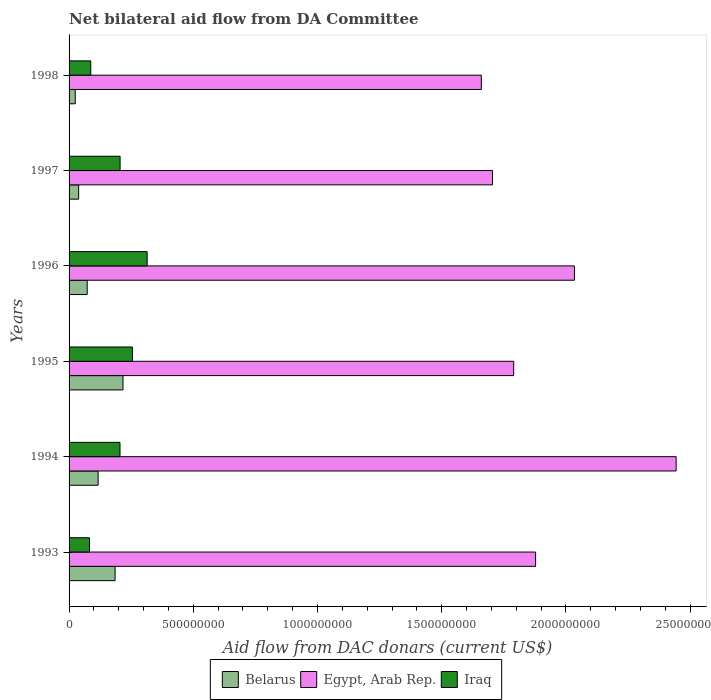How many bars are there on the 1st tick from the top?
Your answer should be compact. 3. How many bars are there on the 2nd tick from the bottom?
Your response must be concise. 3. What is the label of the 6th group of bars from the top?
Your response must be concise. 1993. In how many cases, is the number of bars for a given year not equal to the number of legend labels?
Your answer should be compact. 0. What is the aid flow in in Egypt, Arab Rep. in 1993?
Give a very brief answer. 1.88e+09. Across all years, what is the maximum aid flow in in Iraq?
Offer a very short reply. 3.14e+08. Across all years, what is the minimum aid flow in in Iraq?
Offer a very short reply. 8.23e+07. In which year was the aid flow in in Belarus maximum?
Give a very brief answer. 1995. What is the total aid flow in in Belarus in the graph?
Provide a short and direct response. 6.56e+08. What is the difference between the aid flow in in Iraq in 1995 and that in 1996?
Provide a short and direct response. -5.94e+07. What is the difference between the aid flow in in Belarus in 1998 and the aid flow in in Iraq in 1995?
Your answer should be very brief. -2.30e+08. What is the average aid flow in in Belarus per year?
Provide a succinct answer. 1.09e+08. In the year 1994, what is the difference between the aid flow in in Belarus and aid flow in in Iraq?
Give a very brief answer. -8.81e+07. In how many years, is the aid flow in in Iraq greater than 200000000 US$?
Your answer should be very brief. 4. What is the ratio of the aid flow in in Iraq in 1993 to that in 1997?
Keep it short and to the point. 0.4. Is the aid flow in in Egypt, Arab Rep. in 1996 less than that in 1998?
Make the answer very short. No. Is the difference between the aid flow in in Belarus in 1994 and 1998 greater than the difference between the aid flow in in Iraq in 1994 and 1998?
Your answer should be very brief. No. What is the difference between the highest and the second highest aid flow in in Egypt, Arab Rep.?
Provide a short and direct response. 4.09e+08. What is the difference between the highest and the lowest aid flow in in Iraq?
Your answer should be very brief. 2.32e+08. In how many years, is the aid flow in in Belarus greater than the average aid flow in in Belarus taken over all years?
Give a very brief answer. 3. Is the sum of the aid flow in in Belarus in 1995 and 1996 greater than the maximum aid flow in in Iraq across all years?
Give a very brief answer. No. What does the 2nd bar from the top in 1997 represents?
Provide a short and direct response. Egypt, Arab Rep. What does the 2nd bar from the bottom in 1998 represents?
Give a very brief answer. Egypt, Arab Rep. How many bars are there?
Make the answer very short. 18. Are all the bars in the graph horizontal?
Your answer should be compact. Yes. How many years are there in the graph?
Your response must be concise. 6. What is the difference between two consecutive major ticks on the X-axis?
Your answer should be compact. 5.00e+08. Are the values on the major ticks of X-axis written in scientific E-notation?
Your answer should be very brief. No. Does the graph contain any zero values?
Ensure brevity in your answer.  No. Does the graph contain grids?
Provide a short and direct response. No. How many legend labels are there?
Your answer should be very brief. 3. How are the legend labels stacked?
Make the answer very short. Horizontal. What is the title of the graph?
Make the answer very short. Net bilateral aid flow from DA Committee. What is the label or title of the X-axis?
Your response must be concise. Aid flow from DAC donars (current US$). What is the Aid flow from DAC donars (current US$) in Belarus in 1993?
Your answer should be compact. 1.85e+08. What is the Aid flow from DAC donars (current US$) of Egypt, Arab Rep. in 1993?
Your response must be concise. 1.88e+09. What is the Aid flow from DAC donars (current US$) of Iraq in 1993?
Offer a very short reply. 8.23e+07. What is the Aid flow from DAC donars (current US$) in Belarus in 1994?
Your response must be concise. 1.17e+08. What is the Aid flow from DAC donars (current US$) of Egypt, Arab Rep. in 1994?
Make the answer very short. 2.44e+09. What is the Aid flow from DAC donars (current US$) of Iraq in 1994?
Give a very brief answer. 2.05e+08. What is the Aid flow from DAC donars (current US$) of Belarus in 1995?
Ensure brevity in your answer.  2.17e+08. What is the Aid flow from DAC donars (current US$) in Egypt, Arab Rep. in 1995?
Provide a short and direct response. 1.79e+09. What is the Aid flow from DAC donars (current US$) of Iraq in 1995?
Your response must be concise. 2.55e+08. What is the Aid flow from DAC donars (current US$) of Belarus in 1996?
Provide a short and direct response. 7.30e+07. What is the Aid flow from DAC donars (current US$) in Egypt, Arab Rep. in 1996?
Provide a short and direct response. 2.03e+09. What is the Aid flow from DAC donars (current US$) of Iraq in 1996?
Offer a terse response. 3.14e+08. What is the Aid flow from DAC donars (current US$) in Belarus in 1997?
Keep it short and to the point. 3.86e+07. What is the Aid flow from DAC donars (current US$) of Egypt, Arab Rep. in 1997?
Make the answer very short. 1.70e+09. What is the Aid flow from DAC donars (current US$) of Iraq in 1997?
Provide a short and direct response. 2.05e+08. What is the Aid flow from DAC donars (current US$) in Belarus in 1998?
Ensure brevity in your answer.  2.49e+07. What is the Aid flow from DAC donars (current US$) of Egypt, Arab Rep. in 1998?
Your response must be concise. 1.66e+09. What is the Aid flow from DAC donars (current US$) of Iraq in 1998?
Your response must be concise. 8.74e+07. Across all years, what is the maximum Aid flow from DAC donars (current US$) in Belarus?
Offer a terse response. 2.17e+08. Across all years, what is the maximum Aid flow from DAC donars (current US$) in Egypt, Arab Rep.?
Provide a succinct answer. 2.44e+09. Across all years, what is the maximum Aid flow from DAC donars (current US$) of Iraq?
Offer a terse response. 3.14e+08. Across all years, what is the minimum Aid flow from DAC donars (current US$) in Belarus?
Make the answer very short. 2.49e+07. Across all years, what is the minimum Aid flow from DAC donars (current US$) of Egypt, Arab Rep.?
Keep it short and to the point. 1.66e+09. Across all years, what is the minimum Aid flow from DAC donars (current US$) of Iraq?
Your response must be concise. 8.23e+07. What is the total Aid flow from DAC donars (current US$) in Belarus in the graph?
Make the answer very short. 6.56e+08. What is the total Aid flow from DAC donars (current US$) in Egypt, Arab Rep. in the graph?
Provide a succinct answer. 1.15e+1. What is the total Aid flow from DAC donars (current US$) of Iraq in the graph?
Your answer should be compact. 1.15e+09. What is the difference between the Aid flow from DAC donars (current US$) of Belarus in 1993 and that in 1994?
Your answer should be compact. 6.83e+07. What is the difference between the Aid flow from DAC donars (current US$) of Egypt, Arab Rep. in 1993 and that in 1994?
Provide a succinct answer. -5.66e+08. What is the difference between the Aid flow from DAC donars (current US$) of Iraq in 1993 and that in 1994?
Your response must be concise. -1.23e+08. What is the difference between the Aid flow from DAC donars (current US$) in Belarus in 1993 and that in 1995?
Ensure brevity in your answer.  -3.19e+07. What is the difference between the Aid flow from DAC donars (current US$) of Egypt, Arab Rep. in 1993 and that in 1995?
Keep it short and to the point. 8.82e+07. What is the difference between the Aid flow from DAC donars (current US$) of Iraq in 1993 and that in 1995?
Make the answer very short. -1.73e+08. What is the difference between the Aid flow from DAC donars (current US$) of Belarus in 1993 and that in 1996?
Offer a very short reply. 1.12e+08. What is the difference between the Aid flow from DAC donars (current US$) of Egypt, Arab Rep. in 1993 and that in 1996?
Provide a short and direct response. -1.56e+08. What is the difference between the Aid flow from DAC donars (current US$) of Iraq in 1993 and that in 1996?
Provide a succinct answer. -2.32e+08. What is the difference between the Aid flow from DAC donars (current US$) of Belarus in 1993 and that in 1997?
Give a very brief answer. 1.47e+08. What is the difference between the Aid flow from DAC donars (current US$) in Egypt, Arab Rep. in 1993 and that in 1997?
Your response must be concise. 1.73e+08. What is the difference between the Aid flow from DAC donars (current US$) of Iraq in 1993 and that in 1997?
Your response must be concise. -1.23e+08. What is the difference between the Aid flow from DAC donars (current US$) of Belarus in 1993 and that in 1998?
Your answer should be very brief. 1.60e+08. What is the difference between the Aid flow from DAC donars (current US$) of Egypt, Arab Rep. in 1993 and that in 1998?
Provide a short and direct response. 2.18e+08. What is the difference between the Aid flow from DAC donars (current US$) of Iraq in 1993 and that in 1998?
Offer a very short reply. -5.08e+06. What is the difference between the Aid flow from DAC donars (current US$) of Belarus in 1994 and that in 1995?
Give a very brief answer. -1.00e+08. What is the difference between the Aid flow from DAC donars (current US$) in Egypt, Arab Rep. in 1994 and that in 1995?
Provide a short and direct response. 6.54e+08. What is the difference between the Aid flow from DAC donars (current US$) in Iraq in 1994 and that in 1995?
Offer a terse response. -4.99e+07. What is the difference between the Aid flow from DAC donars (current US$) in Belarus in 1994 and that in 1996?
Keep it short and to the point. 4.39e+07. What is the difference between the Aid flow from DAC donars (current US$) of Egypt, Arab Rep. in 1994 and that in 1996?
Make the answer very short. 4.09e+08. What is the difference between the Aid flow from DAC donars (current US$) of Iraq in 1994 and that in 1996?
Your answer should be compact. -1.09e+08. What is the difference between the Aid flow from DAC donars (current US$) in Belarus in 1994 and that in 1997?
Offer a terse response. 7.83e+07. What is the difference between the Aid flow from DAC donars (current US$) in Egypt, Arab Rep. in 1994 and that in 1997?
Your response must be concise. 7.39e+08. What is the difference between the Aid flow from DAC donars (current US$) of Iraq in 1994 and that in 1997?
Provide a succinct answer. -3.50e+05. What is the difference between the Aid flow from DAC donars (current US$) in Belarus in 1994 and that in 1998?
Your response must be concise. 9.20e+07. What is the difference between the Aid flow from DAC donars (current US$) of Egypt, Arab Rep. in 1994 and that in 1998?
Give a very brief answer. 7.84e+08. What is the difference between the Aid flow from DAC donars (current US$) in Iraq in 1994 and that in 1998?
Your answer should be very brief. 1.18e+08. What is the difference between the Aid flow from DAC donars (current US$) in Belarus in 1995 and that in 1996?
Provide a succinct answer. 1.44e+08. What is the difference between the Aid flow from DAC donars (current US$) of Egypt, Arab Rep. in 1995 and that in 1996?
Your response must be concise. -2.45e+08. What is the difference between the Aid flow from DAC donars (current US$) of Iraq in 1995 and that in 1996?
Make the answer very short. -5.94e+07. What is the difference between the Aid flow from DAC donars (current US$) in Belarus in 1995 and that in 1997?
Your answer should be compact. 1.78e+08. What is the difference between the Aid flow from DAC donars (current US$) of Egypt, Arab Rep. in 1995 and that in 1997?
Ensure brevity in your answer.  8.53e+07. What is the difference between the Aid flow from DAC donars (current US$) of Iraq in 1995 and that in 1997?
Your answer should be compact. 4.95e+07. What is the difference between the Aid flow from DAC donars (current US$) in Belarus in 1995 and that in 1998?
Ensure brevity in your answer.  1.92e+08. What is the difference between the Aid flow from DAC donars (current US$) in Egypt, Arab Rep. in 1995 and that in 1998?
Offer a terse response. 1.30e+08. What is the difference between the Aid flow from DAC donars (current US$) in Iraq in 1995 and that in 1998?
Your answer should be compact. 1.67e+08. What is the difference between the Aid flow from DAC donars (current US$) in Belarus in 1996 and that in 1997?
Offer a very short reply. 3.43e+07. What is the difference between the Aid flow from DAC donars (current US$) in Egypt, Arab Rep. in 1996 and that in 1997?
Make the answer very short. 3.30e+08. What is the difference between the Aid flow from DAC donars (current US$) of Iraq in 1996 and that in 1997?
Offer a very short reply. 1.09e+08. What is the difference between the Aid flow from DAC donars (current US$) in Belarus in 1996 and that in 1998?
Give a very brief answer. 4.81e+07. What is the difference between the Aid flow from DAC donars (current US$) of Egypt, Arab Rep. in 1996 and that in 1998?
Your answer should be compact. 3.75e+08. What is the difference between the Aid flow from DAC donars (current US$) of Iraq in 1996 and that in 1998?
Your response must be concise. 2.27e+08. What is the difference between the Aid flow from DAC donars (current US$) of Belarus in 1997 and that in 1998?
Provide a succinct answer. 1.38e+07. What is the difference between the Aid flow from DAC donars (current US$) of Egypt, Arab Rep. in 1997 and that in 1998?
Your response must be concise. 4.49e+07. What is the difference between the Aid flow from DAC donars (current US$) of Iraq in 1997 and that in 1998?
Give a very brief answer. 1.18e+08. What is the difference between the Aid flow from DAC donars (current US$) in Belarus in 1993 and the Aid flow from DAC donars (current US$) in Egypt, Arab Rep. in 1994?
Offer a very short reply. -2.26e+09. What is the difference between the Aid flow from DAC donars (current US$) of Belarus in 1993 and the Aid flow from DAC donars (current US$) of Iraq in 1994?
Offer a terse response. -1.98e+07. What is the difference between the Aid flow from DAC donars (current US$) of Egypt, Arab Rep. in 1993 and the Aid flow from DAC donars (current US$) of Iraq in 1994?
Offer a terse response. 1.67e+09. What is the difference between the Aid flow from DAC donars (current US$) in Belarus in 1993 and the Aid flow from DAC donars (current US$) in Egypt, Arab Rep. in 1995?
Your answer should be compact. -1.60e+09. What is the difference between the Aid flow from DAC donars (current US$) of Belarus in 1993 and the Aid flow from DAC donars (current US$) of Iraq in 1995?
Ensure brevity in your answer.  -6.97e+07. What is the difference between the Aid flow from DAC donars (current US$) of Egypt, Arab Rep. in 1993 and the Aid flow from DAC donars (current US$) of Iraq in 1995?
Offer a very short reply. 1.62e+09. What is the difference between the Aid flow from DAC donars (current US$) in Belarus in 1993 and the Aid flow from DAC donars (current US$) in Egypt, Arab Rep. in 1996?
Give a very brief answer. -1.85e+09. What is the difference between the Aid flow from DAC donars (current US$) of Belarus in 1993 and the Aid flow from DAC donars (current US$) of Iraq in 1996?
Ensure brevity in your answer.  -1.29e+08. What is the difference between the Aid flow from DAC donars (current US$) in Egypt, Arab Rep. in 1993 and the Aid flow from DAC donars (current US$) in Iraq in 1996?
Your answer should be compact. 1.56e+09. What is the difference between the Aid flow from DAC donars (current US$) of Belarus in 1993 and the Aid flow from DAC donars (current US$) of Egypt, Arab Rep. in 1997?
Provide a succinct answer. -1.52e+09. What is the difference between the Aid flow from DAC donars (current US$) of Belarus in 1993 and the Aid flow from DAC donars (current US$) of Iraq in 1997?
Keep it short and to the point. -2.02e+07. What is the difference between the Aid flow from DAC donars (current US$) in Egypt, Arab Rep. in 1993 and the Aid flow from DAC donars (current US$) in Iraq in 1997?
Provide a succinct answer. 1.67e+09. What is the difference between the Aid flow from DAC donars (current US$) of Belarus in 1993 and the Aid flow from DAC donars (current US$) of Egypt, Arab Rep. in 1998?
Your response must be concise. -1.47e+09. What is the difference between the Aid flow from DAC donars (current US$) of Belarus in 1993 and the Aid flow from DAC donars (current US$) of Iraq in 1998?
Give a very brief answer. 9.78e+07. What is the difference between the Aid flow from DAC donars (current US$) of Egypt, Arab Rep. in 1993 and the Aid flow from DAC donars (current US$) of Iraq in 1998?
Provide a short and direct response. 1.79e+09. What is the difference between the Aid flow from DAC donars (current US$) of Belarus in 1994 and the Aid flow from DAC donars (current US$) of Egypt, Arab Rep. in 1995?
Keep it short and to the point. -1.67e+09. What is the difference between the Aid flow from DAC donars (current US$) of Belarus in 1994 and the Aid flow from DAC donars (current US$) of Iraq in 1995?
Give a very brief answer. -1.38e+08. What is the difference between the Aid flow from DAC donars (current US$) of Egypt, Arab Rep. in 1994 and the Aid flow from DAC donars (current US$) of Iraq in 1995?
Offer a very short reply. 2.19e+09. What is the difference between the Aid flow from DAC donars (current US$) in Belarus in 1994 and the Aid flow from DAC donars (current US$) in Egypt, Arab Rep. in 1996?
Make the answer very short. -1.92e+09. What is the difference between the Aid flow from DAC donars (current US$) of Belarus in 1994 and the Aid flow from DAC donars (current US$) of Iraq in 1996?
Offer a very short reply. -1.97e+08. What is the difference between the Aid flow from DAC donars (current US$) of Egypt, Arab Rep. in 1994 and the Aid flow from DAC donars (current US$) of Iraq in 1996?
Keep it short and to the point. 2.13e+09. What is the difference between the Aid flow from DAC donars (current US$) of Belarus in 1994 and the Aid flow from DAC donars (current US$) of Egypt, Arab Rep. in 1997?
Your answer should be very brief. -1.59e+09. What is the difference between the Aid flow from DAC donars (current US$) in Belarus in 1994 and the Aid flow from DAC donars (current US$) in Iraq in 1997?
Offer a very short reply. -8.85e+07. What is the difference between the Aid flow from DAC donars (current US$) in Egypt, Arab Rep. in 1994 and the Aid flow from DAC donars (current US$) in Iraq in 1997?
Offer a terse response. 2.24e+09. What is the difference between the Aid flow from DAC donars (current US$) in Belarus in 1994 and the Aid flow from DAC donars (current US$) in Egypt, Arab Rep. in 1998?
Ensure brevity in your answer.  -1.54e+09. What is the difference between the Aid flow from DAC donars (current US$) in Belarus in 1994 and the Aid flow from DAC donars (current US$) in Iraq in 1998?
Your response must be concise. 2.95e+07. What is the difference between the Aid flow from DAC donars (current US$) in Egypt, Arab Rep. in 1994 and the Aid flow from DAC donars (current US$) in Iraq in 1998?
Make the answer very short. 2.36e+09. What is the difference between the Aid flow from DAC donars (current US$) in Belarus in 1995 and the Aid flow from DAC donars (current US$) in Egypt, Arab Rep. in 1996?
Offer a very short reply. -1.82e+09. What is the difference between the Aid flow from DAC donars (current US$) in Belarus in 1995 and the Aid flow from DAC donars (current US$) in Iraq in 1996?
Keep it short and to the point. -9.72e+07. What is the difference between the Aid flow from DAC donars (current US$) of Egypt, Arab Rep. in 1995 and the Aid flow from DAC donars (current US$) of Iraq in 1996?
Provide a short and direct response. 1.48e+09. What is the difference between the Aid flow from DAC donars (current US$) of Belarus in 1995 and the Aid flow from DAC donars (current US$) of Egypt, Arab Rep. in 1997?
Your response must be concise. -1.49e+09. What is the difference between the Aid flow from DAC donars (current US$) of Belarus in 1995 and the Aid flow from DAC donars (current US$) of Iraq in 1997?
Ensure brevity in your answer.  1.17e+07. What is the difference between the Aid flow from DAC donars (current US$) in Egypt, Arab Rep. in 1995 and the Aid flow from DAC donars (current US$) in Iraq in 1997?
Make the answer very short. 1.58e+09. What is the difference between the Aid flow from DAC donars (current US$) of Belarus in 1995 and the Aid flow from DAC donars (current US$) of Egypt, Arab Rep. in 1998?
Your answer should be compact. -1.44e+09. What is the difference between the Aid flow from DAC donars (current US$) in Belarus in 1995 and the Aid flow from DAC donars (current US$) in Iraq in 1998?
Your response must be concise. 1.30e+08. What is the difference between the Aid flow from DAC donars (current US$) in Egypt, Arab Rep. in 1995 and the Aid flow from DAC donars (current US$) in Iraq in 1998?
Give a very brief answer. 1.70e+09. What is the difference between the Aid flow from DAC donars (current US$) in Belarus in 1996 and the Aid flow from DAC donars (current US$) in Egypt, Arab Rep. in 1997?
Offer a very short reply. -1.63e+09. What is the difference between the Aid flow from DAC donars (current US$) in Belarus in 1996 and the Aid flow from DAC donars (current US$) in Iraq in 1997?
Provide a short and direct response. -1.32e+08. What is the difference between the Aid flow from DAC donars (current US$) in Egypt, Arab Rep. in 1996 and the Aid flow from DAC donars (current US$) in Iraq in 1997?
Offer a terse response. 1.83e+09. What is the difference between the Aid flow from DAC donars (current US$) in Belarus in 1996 and the Aid flow from DAC donars (current US$) in Egypt, Arab Rep. in 1998?
Your response must be concise. -1.59e+09. What is the difference between the Aid flow from DAC donars (current US$) in Belarus in 1996 and the Aid flow from DAC donars (current US$) in Iraq in 1998?
Offer a terse response. -1.44e+07. What is the difference between the Aid flow from DAC donars (current US$) of Egypt, Arab Rep. in 1996 and the Aid flow from DAC donars (current US$) of Iraq in 1998?
Your response must be concise. 1.95e+09. What is the difference between the Aid flow from DAC donars (current US$) in Belarus in 1997 and the Aid flow from DAC donars (current US$) in Egypt, Arab Rep. in 1998?
Keep it short and to the point. -1.62e+09. What is the difference between the Aid flow from DAC donars (current US$) of Belarus in 1997 and the Aid flow from DAC donars (current US$) of Iraq in 1998?
Offer a terse response. -4.88e+07. What is the difference between the Aid flow from DAC donars (current US$) of Egypt, Arab Rep. in 1997 and the Aid flow from DAC donars (current US$) of Iraq in 1998?
Make the answer very short. 1.62e+09. What is the average Aid flow from DAC donars (current US$) in Belarus per year?
Your response must be concise. 1.09e+08. What is the average Aid flow from DAC donars (current US$) of Egypt, Arab Rep. per year?
Provide a short and direct response. 1.92e+09. What is the average Aid flow from DAC donars (current US$) of Iraq per year?
Keep it short and to the point. 1.92e+08. In the year 1993, what is the difference between the Aid flow from DAC donars (current US$) of Belarus and Aid flow from DAC donars (current US$) of Egypt, Arab Rep.?
Provide a succinct answer. -1.69e+09. In the year 1993, what is the difference between the Aid flow from DAC donars (current US$) in Belarus and Aid flow from DAC donars (current US$) in Iraq?
Offer a terse response. 1.03e+08. In the year 1993, what is the difference between the Aid flow from DAC donars (current US$) in Egypt, Arab Rep. and Aid flow from DAC donars (current US$) in Iraq?
Offer a very short reply. 1.80e+09. In the year 1994, what is the difference between the Aid flow from DAC donars (current US$) in Belarus and Aid flow from DAC donars (current US$) in Egypt, Arab Rep.?
Your answer should be very brief. -2.33e+09. In the year 1994, what is the difference between the Aid flow from DAC donars (current US$) in Belarus and Aid flow from DAC donars (current US$) in Iraq?
Offer a very short reply. -8.81e+07. In the year 1994, what is the difference between the Aid flow from DAC donars (current US$) of Egypt, Arab Rep. and Aid flow from DAC donars (current US$) of Iraq?
Make the answer very short. 2.24e+09. In the year 1995, what is the difference between the Aid flow from DAC donars (current US$) in Belarus and Aid flow from DAC donars (current US$) in Egypt, Arab Rep.?
Offer a terse response. -1.57e+09. In the year 1995, what is the difference between the Aid flow from DAC donars (current US$) of Belarus and Aid flow from DAC donars (current US$) of Iraq?
Your response must be concise. -3.78e+07. In the year 1995, what is the difference between the Aid flow from DAC donars (current US$) in Egypt, Arab Rep. and Aid flow from DAC donars (current US$) in Iraq?
Give a very brief answer. 1.53e+09. In the year 1996, what is the difference between the Aid flow from DAC donars (current US$) of Belarus and Aid flow from DAC donars (current US$) of Egypt, Arab Rep.?
Provide a short and direct response. -1.96e+09. In the year 1996, what is the difference between the Aid flow from DAC donars (current US$) of Belarus and Aid flow from DAC donars (current US$) of Iraq?
Your answer should be compact. -2.41e+08. In the year 1996, what is the difference between the Aid flow from DAC donars (current US$) of Egypt, Arab Rep. and Aid flow from DAC donars (current US$) of Iraq?
Offer a terse response. 1.72e+09. In the year 1997, what is the difference between the Aid flow from DAC donars (current US$) of Belarus and Aid flow from DAC donars (current US$) of Egypt, Arab Rep.?
Ensure brevity in your answer.  -1.67e+09. In the year 1997, what is the difference between the Aid flow from DAC donars (current US$) of Belarus and Aid flow from DAC donars (current US$) of Iraq?
Make the answer very short. -1.67e+08. In the year 1997, what is the difference between the Aid flow from DAC donars (current US$) in Egypt, Arab Rep. and Aid flow from DAC donars (current US$) in Iraq?
Offer a very short reply. 1.50e+09. In the year 1998, what is the difference between the Aid flow from DAC donars (current US$) in Belarus and Aid flow from DAC donars (current US$) in Egypt, Arab Rep.?
Your response must be concise. -1.63e+09. In the year 1998, what is the difference between the Aid flow from DAC donars (current US$) of Belarus and Aid flow from DAC donars (current US$) of Iraq?
Your response must be concise. -6.25e+07. In the year 1998, what is the difference between the Aid flow from DAC donars (current US$) in Egypt, Arab Rep. and Aid flow from DAC donars (current US$) in Iraq?
Offer a terse response. 1.57e+09. What is the ratio of the Aid flow from DAC donars (current US$) of Belarus in 1993 to that in 1994?
Provide a succinct answer. 1.58. What is the ratio of the Aid flow from DAC donars (current US$) of Egypt, Arab Rep. in 1993 to that in 1994?
Provide a short and direct response. 0.77. What is the ratio of the Aid flow from DAC donars (current US$) in Iraq in 1993 to that in 1994?
Provide a short and direct response. 0.4. What is the ratio of the Aid flow from DAC donars (current US$) of Belarus in 1993 to that in 1995?
Offer a very short reply. 0.85. What is the ratio of the Aid flow from DAC donars (current US$) of Egypt, Arab Rep. in 1993 to that in 1995?
Make the answer very short. 1.05. What is the ratio of the Aid flow from DAC donars (current US$) of Iraq in 1993 to that in 1995?
Give a very brief answer. 0.32. What is the ratio of the Aid flow from DAC donars (current US$) of Belarus in 1993 to that in 1996?
Make the answer very short. 2.54. What is the ratio of the Aid flow from DAC donars (current US$) of Egypt, Arab Rep. in 1993 to that in 1996?
Provide a succinct answer. 0.92. What is the ratio of the Aid flow from DAC donars (current US$) in Iraq in 1993 to that in 1996?
Provide a short and direct response. 0.26. What is the ratio of the Aid flow from DAC donars (current US$) of Belarus in 1993 to that in 1997?
Keep it short and to the point. 4.8. What is the ratio of the Aid flow from DAC donars (current US$) of Egypt, Arab Rep. in 1993 to that in 1997?
Offer a terse response. 1.1. What is the ratio of the Aid flow from DAC donars (current US$) of Iraq in 1993 to that in 1997?
Your answer should be compact. 0.4. What is the ratio of the Aid flow from DAC donars (current US$) in Belarus in 1993 to that in 1998?
Provide a short and direct response. 7.45. What is the ratio of the Aid flow from DAC donars (current US$) of Egypt, Arab Rep. in 1993 to that in 1998?
Your answer should be very brief. 1.13. What is the ratio of the Aid flow from DAC donars (current US$) of Iraq in 1993 to that in 1998?
Make the answer very short. 0.94. What is the ratio of the Aid flow from DAC donars (current US$) of Belarus in 1994 to that in 1995?
Provide a short and direct response. 0.54. What is the ratio of the Aid flow from DAC donars (current US$) of Egypt, Arab Rep. in 1994 to that in 1995?
Ensure brevity in your answer.  1.37. What is the ratio of the Aid flow from DAC donars (current US$) of Iraq in 1994 to that in 1995?
Ensure brevity in your answer.  0.8. What is the ratio of the Aid flow from DAC donars (current US$) in Belarus in 1994 to that in 1996?
Offer a very short reply. 1.6. What is the ratio of the Aid flow from DAC donars (current US$) in Egypt, Arab Rep. in 1994 to that in 1996?
Keep it short and to the point. 1.2. What is the ratio of the Aid flow from DAC donars (current US$) in Iraq in 1994 to that in 1996?
Your answer should be compact. 0.65. What is the ratio of the Aid flow from DAC donars (current US$) of Belarus in 1994 to that in 1997?
Your answer should be compact. 3.03. What is the ratio of the Aid flow from DAC donars (current US$) of Egypt, Arab Rep. in 1994 to that in 1997?
Offer a very short reply. 1.43. What is the ratio of the Aid flow from DAC donars (current US$) of Belarus in 1994 to that in 1998?
Give a very brief answer. 4.7. What is the ratio of the Aid flow from DAC donars (current US$) in Egypt, Arab Rep. in 1994 to that in 1998?
Give a very brief answer. 1.47. What is the ratio of the Aid flow from DAC donars (current US$) of Iraq in 1994 to that in 1998?
Offer a terse response. 2.35. What is the ratio of the Aid flow from DAC donars (current US$) of Belarus in 1995 to that in 1996?
Your response must be concise. 2.98. What is the ratio of the Aid flow from DAC donars (current US$) in Egypt, Arab Rep. in 1995 to that in 1996?
Your response must be concise. 0.88. What is the ratio of the Aid flow from DAC donars (current US$) in Iraq in 1995 to that in 1996?
Give a very brief answer. 0.81. What is the ratio of the Aid flow from DAC donars (current US$) in Belarus in 1995 to that in 1997?
Keep it short and to the point. 5.62. What is the ratio of the Aid flow from DAC donars (current US$) in Iraq in 1995 to that in 1997?
Give a very brief answer. 1.24. What is the ratio of the Aid flow from DAC donars (current US$) of Belarus in 1995 to that in 1998?
Your answer should be compact. 8.73. What is the ratio of the Aid flow from DAC donars (current US$) in Egypt, Arab Rep. in 1995 to that in 1998?
Offer a very short reply. 1.08. What is the ratio of the Aid flow from DAC donars (current US$) of Iraq in 1995 to that in 1998?
Keep it short and to the point. 2.92. What is the ratio of the Aid flow from DAC donars (current US$) in Belarus in 1996 to that in 1997?
Make the answer very short. 1.89. What is the ratio of the Aid flow from DAC donars (current US$) of Egypt, Arab Rep. in 1996 to that in 1997?
Ensure brevity in your answer.  1.19. What is the ratio of the Aid flow from DAC donars (current US$) of Iraq in 1996 to that in 1997?
Your response must be concise. 1.53. What is the ratio of the Aid flow from DAC donars (current US$) in Belarus in 1996 to that in 1998?
Make the answer very short. 2.93. What is the ratio of the Aid flow from DAC donars (current US$) of Egypt, Arab Rep. in 1996 to that in 1998?
Make the answer very short. 1.23. What is the ratio of the Aid flow from DAC donars (current US$) of Iraq in 1996 to that in 1998?
Your response must be concise. 3.6. What is the ratio of the Aid flow from DAC donars (current US$) in Belarus in 1997 to that in 1998?
Provide a succinct answer. 1.55. What is the ratio of the Aid flow from DAC donars (current US$) of Egypt, Arab Rep. in 1997 to that in 1998?
Offer a terse response. 1.03. What is the ratio of the Aid flow from DAC donars (current US$) in Iraq in 1997 to that in 1998?
Your answer should be very brief. 2.35. What is the difference between the highest and the second highest Aid flow from DAC donars (current US$) in Belarus?
Ensure brevity in your answer.  3.19e+07. What is the difference between the highest and the second highest Aid flow from DAC donars (current US$) in Egypt, Arab Rep.?
Ensure brevity in your answer.  4.09e+08. What is the difference between the highest and the second highest Aid flow from DAC donars (current US$) of Iraq?
Offer a terse response. 5.94e+07. What is the difference between the highest and the lowest Aid flow from DAC donars (current US$) of Belarus?
Offer a terse response. 1.92e+08. What is the difference between the highest and the lowest Aid flow from DAC donars (current US$) of Egypt, Arab Rep.?
Your response must be concise. 7.84e+08. What is the difference between the highest and the lowest Aid flow from DAC donars (current US$) in Iraq?
Your answer should be compact. 2.32e+08. 